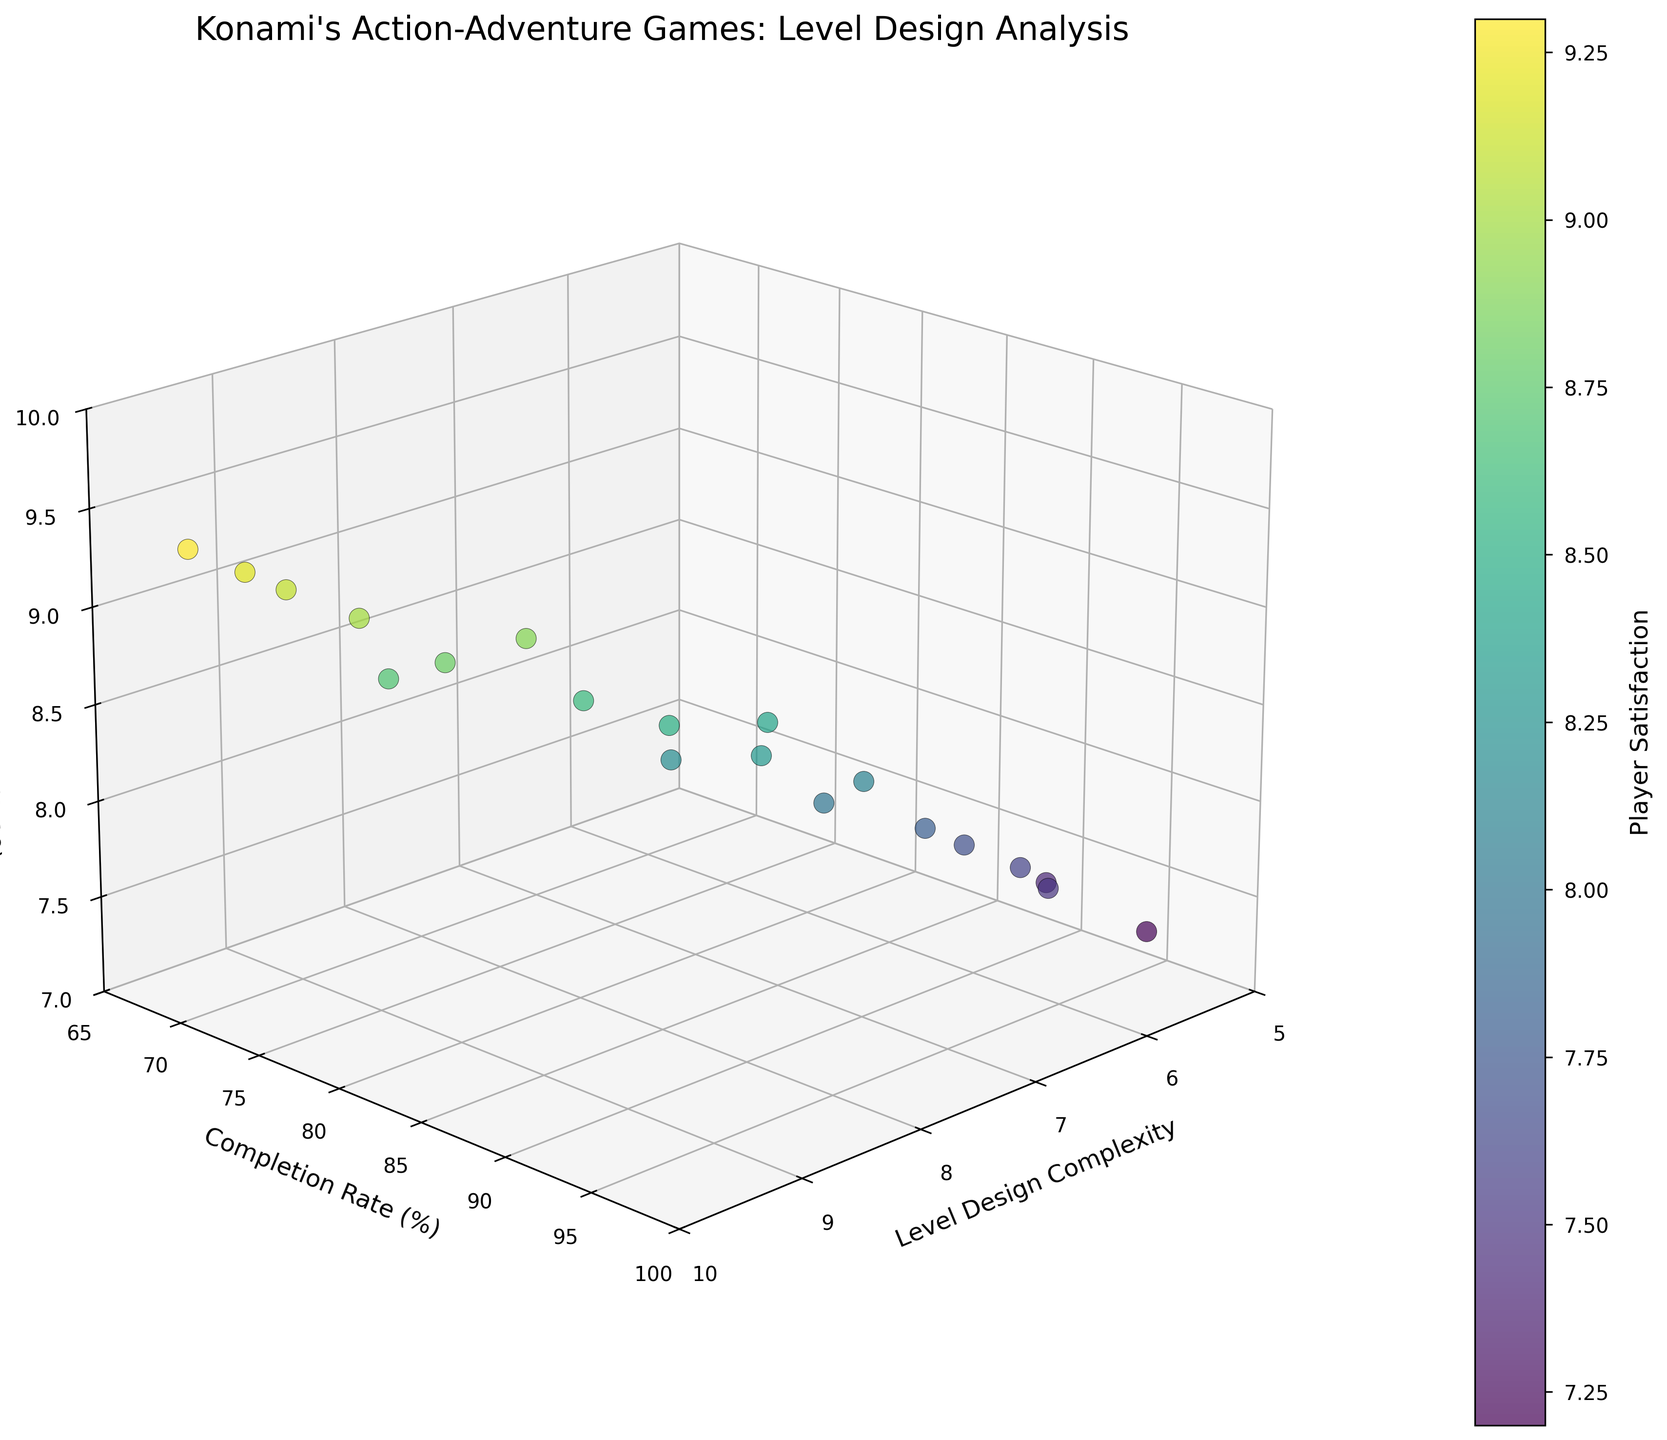What is the title of the plot? The title is usually displayed at the top of the figure and often describes the main focus. Here, the title is "Konami's Action-Adventure Games: Level Design Analysis."
Answer: Konami's Action-Adventure Games: Level Design Analysis How many data points are shown in the plot? By visually counting the number of points plotted in the 3D scatter plot, we can see that there are 20 data points.
Answer: 20 What range of values is displayed on the y-axis (Completion Rate (%))? By observing the y-axis, the plot displays values ranging from 65% to 100%.
Answer: 65% to 100% Which axis represents Player Satisfaction? By looking at the axis labels, it is clear that the z-axis represents Player Satisfaction (1-10).
Answer: z-axis What can you infer about the relationship between Level Design Complexity and Player Satisfaction? By observing the points along the x-axis (Level Design Complexity) and z-axis (Player Satisfaction), it appears that higher complexity often correlates with higher satisfaction, though there are exceptions.
Answer: Higher complexity often correlates with higher satisfaction Which data point has the highest Player Satisfaction score, and what is its Level Design Complexity and Completion Rate? By identifying the highest z-value (Player Satisfaction) and checking its corresponding x and y values, we find that the highest satisfaction score (9.3) has a Level Design Complexity of 9.6 and a Completion Rate of 68%.
Answer: 9.6, 68% Is there a noticeable trend between Completion Rate and Player Satisfaction? By visually analyzing the plot, it appears that higher Completion Rates tend to have moderately high Player Satisfaction scores, but the absolute highest satisfaction scores are associated with slightly lower completion rates.
Answer: Moderate correlation, inverse in highest scores Which data point has the lowest Level Design Complexity and what are its Completion Rate and Player Satisfaction scores? The data point with the lowest Level Design Complexity (5.2) has a Completion Rate of 95% and a Player Satisfaction score of 7.2.
Answer: 95%, 7.2 What is the average Player Satisfaction score for data points with a Level Design Complexity above 8.0? Identify points with Level Design Complexity > 8.0 (8.9, 9.2, 9.6, 8.3, 9.0, 8.7, 9.4). Sum their Player Satisfaction scores (8.7, 9.1, 9.3, 8.9, 9.0, 8.8, 9.2), which totals 63.0. The average is 63.0/7 = 9.0.
Answer: 9.0 